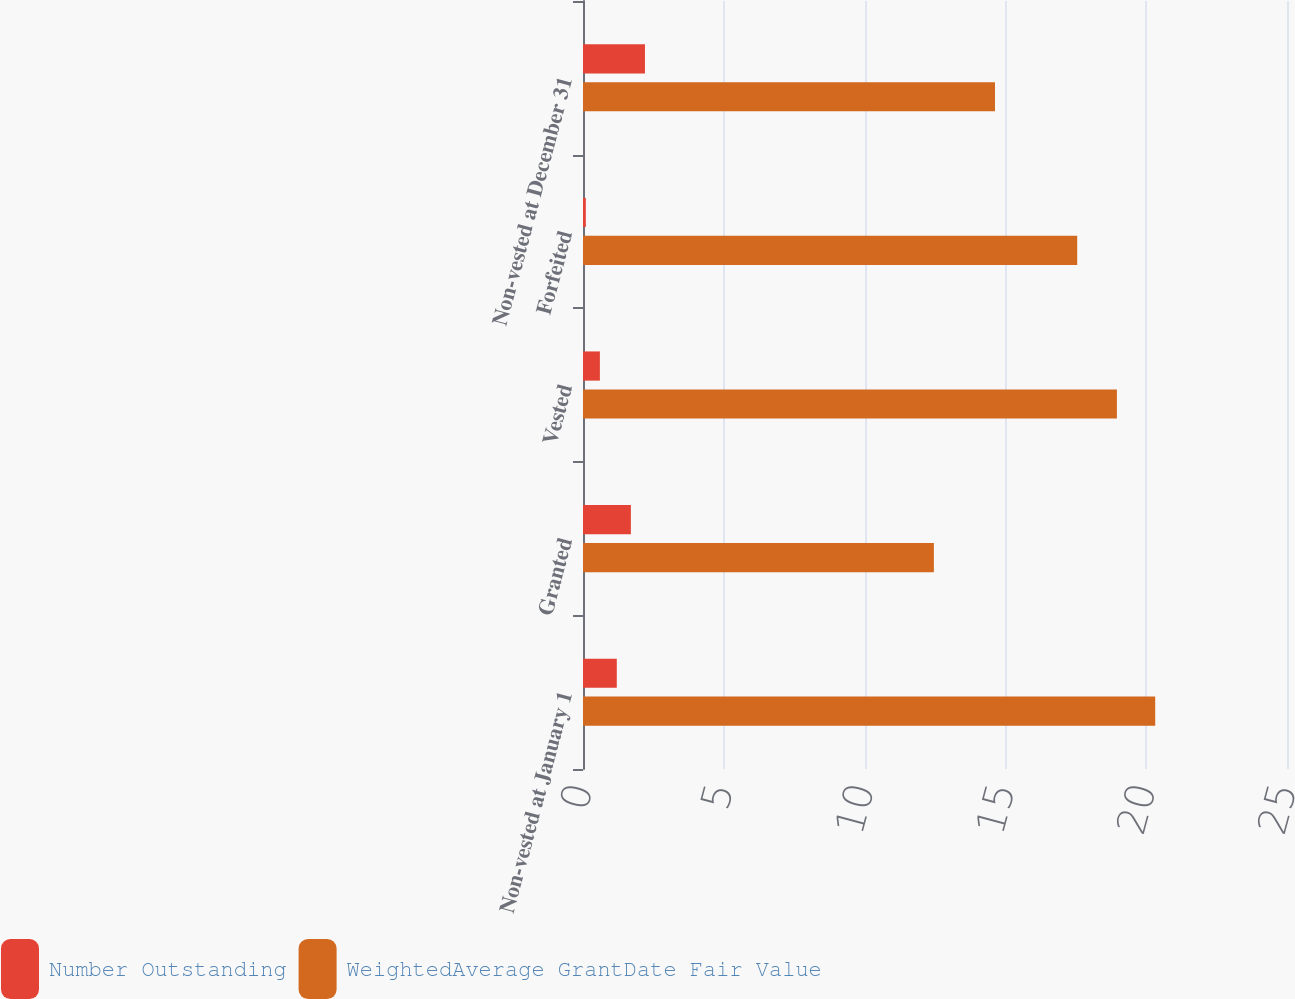Convert chart. <chart><loc_0><loc_0><loc_500><loc_500><stacked_bar_chart><ecel><fcel>Non-vested at January 1<fcel>Granted<fcel>Vested<fcel>Forfeited<fcel>Non-vested at December 31<nl><fcel>Number Outstanding<fcel>1.2<fcel>1.7<fcel>0.6<fcel>0.1<fcel>2.2<nl><fcel>WeightedAverage GrantDate Fair Value<fcel>20.32<fcel>12.46<fcel>18.96<fcel>17.55<fcel>14.63<nl></chart> 